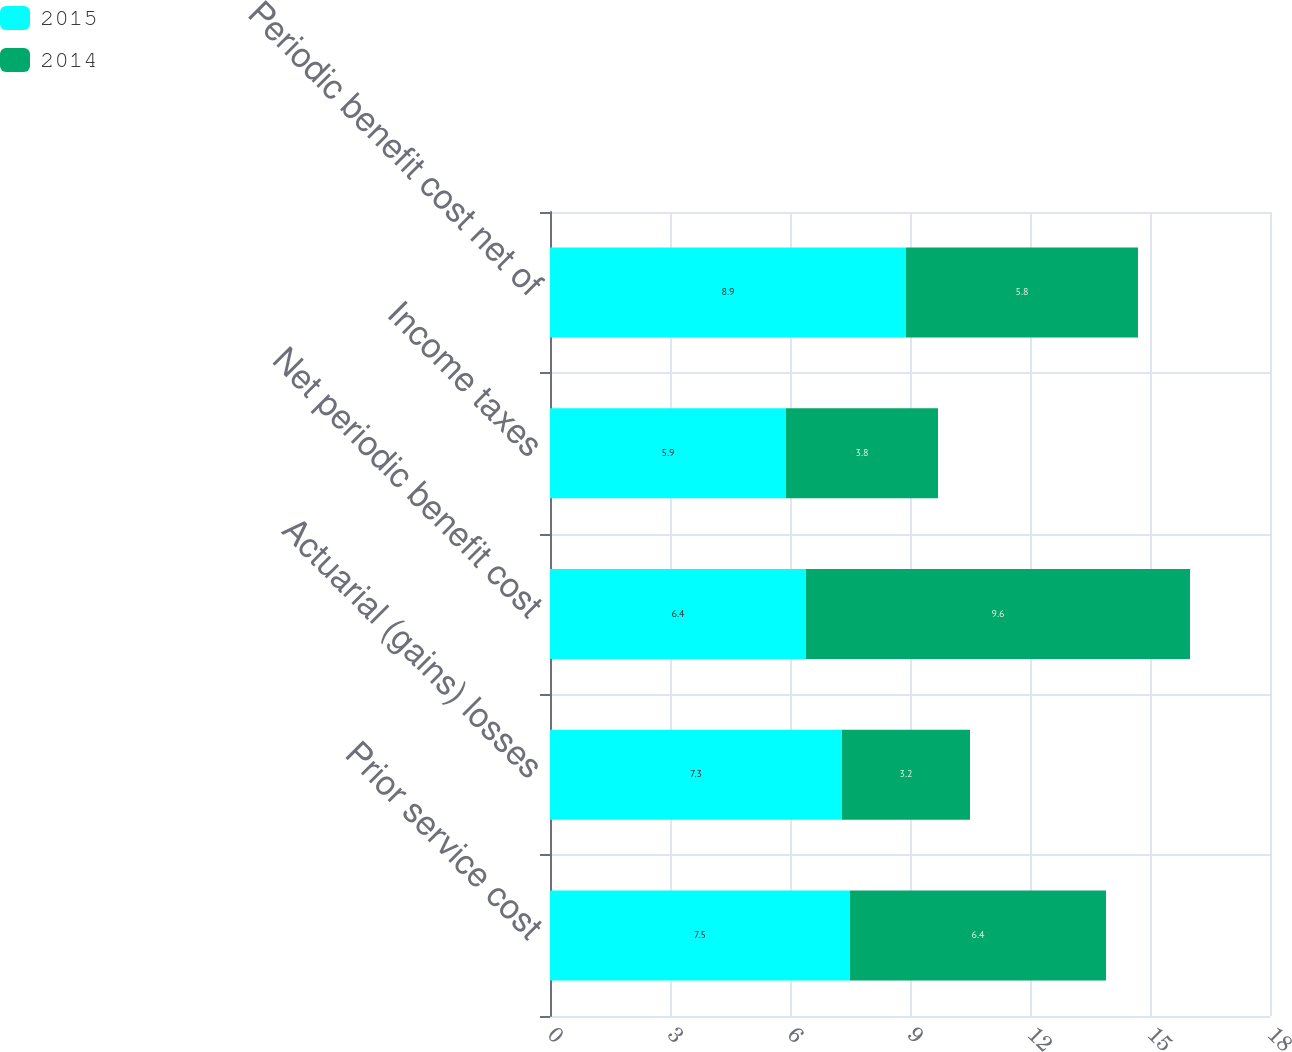Convert chart. <chart><loc_0><loc_0><loc_500><loc_500><stacked_bar_chart><ecel><fcel>Prior service cost<fcel>Actuarial (gains) losses<fcel>Net periodic benefit cost<fcel>Income taxes<fcel>Periodic benefit cost net of<nl><fcel>2015<fcel>7.5<fcel>7.3<fcel>6.4<fcel>5.9<fcel>8.9<nl><fcel>2014<fcel>6.4<fcel>3.2<fcel>9.6<fcel>3.8<fcel>5.8<nl></chart> 